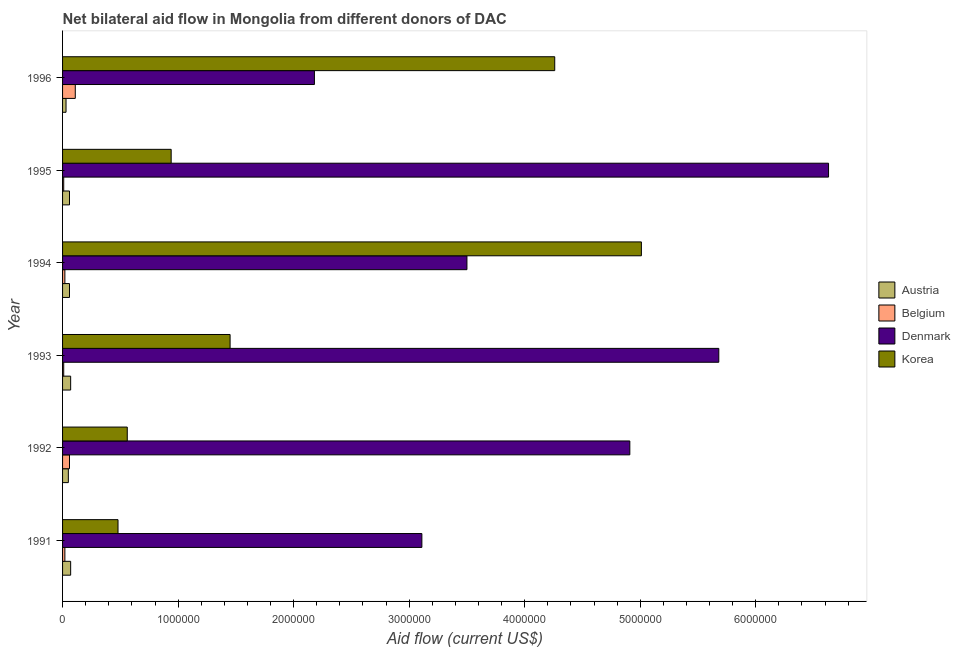How many different coloured bars are there?
Offer a very short reply. 4. Are the number of bars per tick equal to the number of legend labels?
Keep it short and to the point. Yes. Are the number of bars on each tick of the Y-axis equal?
Your answer should be compact. Yes. How many bars are there on the 1st tick from the top?
Offer a very short reply. 4. In how many cases, is the number of bars for a given year not equal to the number of legend labels?
Ensure brevity in your answer.  0. What is the amount of aid given by korea in 1993?
Your answer should be compact. 1.45e+06. Across all years, what is the maximum amount of aid given by austria?
Your response must be concise. 7.00e+04. Across all years, what is the minimum amount of aid given by austria?
Your answer should be very brief. 3.00e+04. In which year was the amount of aid given by korea maximum?
Provide a succinct answer. 1994. In which year was the amount of aid given by austria minimum?
Ensure brevity in your answer.  1996. What is the total amount of aid given by belgium in the graph?
Your answer should be very brief. 2.30e+05. What is the difference between the amount of aid given by austria in 1995 and that in 1996?
Keep it short and to the point. 3.00e+04. What is the average amount of aid given by belgium per year?
Keep it short and to the point. 3.83e+04. In the year 1996, what is the difference between the amount of aid given by austria and amount of aid given by belgium?
Offer a very short reply. -8.00e+04. In how many years, is the amount of aid given by austria greater than 2400000 US$?
Provide a short and direct response. 0. What is the ratio of the amount of aid given by korea in 1994 to that in 1996?
Keep it short and to the point. 1.18. Is the amount of aid given by austria in 1993 less than that in 1995?
Ensure brevity in your answer.  No. What is the difference between the highest and the second highest amount of aid given by korea?
Your answer should be very brief. 7.50e+05. What is the difference between the highest and the lowest amount of aid given by denmark?
Offer a very short reply. 4.45e+06. What does the 3rd bar from the bottom in 1991 represents?
Offer a terse response. Denmark. Are all the bars in the graph horizontal?
Your answer should be compact. Yes. How many years are there in the graph?
Ensure brevity in your answer.  6. Does the graph contain any zero values?
Your answer should be compact. No. What is the title of the graph?
Make the answer very short. Net bilateral aid flow in Mongolia from different donors of DAC. Does "Custom duties" appear as one of the legend labels in the graph?
Offer a terse response. No. What is the label or title of the X-axis?
Offer a terse response. Aid flow (current US$). What is the label or title of the Y-axis?
Give a very brief answer. Year. What is the Aid flow (current US$) in Denmark in 1991?
Your answer should be very brief. 3.11e+06. What is the Aid flow (current US$) in Korea in 1991?
Ensure brevity in your answer.  4.80e+05. What is the Aid flow (current US$) of Austria in 1992?
Keep it short and to the point. 5.00e+04. What is the Aid flow (current US$) in Denmark in 1992?
Offer a very short reply. 4.91e+06. What is the Aid flow (current US$) in Korea in 1992?
Your response must be concise. 5.60e+05. What is the Aid flow (current US$) of Denmark in 1993?
Provide a succinct answer. 5.68e+06. What is the Aid flow (current US$) in Korea in 1993?
Ensure brevity in your answer.  1.45e+06. What is the Aid flow (current US$) in Austria in 1994?
Your response must be concise. 6.00e+04. What is the Aid flow (current US$) of Denmark in 1994?
Provide a succinct answer. 3.50e+06. What is the Aid flow (current US$) in Korea in 1994?
Offer a very short reply. 5.01e+06. What is the Aid flow (current US$) in Austria in 1995?
Provide a short and direct response. 6.00e+04. What is the Aid flow (current US$) of Denmark in 1995?
Your answer should be very brief. 6.63e+06. What is the Aid flow (current US$) in Korea in 1995?
Offer a very short reply. 9.40e+05. What is the Aid flow (current US$) of Denmark in 1996?
Provide a succinct answer. 2.18e+06. What is the Aid flow (current US$) of Korea in 1996?
Give a very brief answer. 4.26e+06. Across all years, what is the maximum Aid flow (current US$) of Austria?
Keep it short and to the point. 7.00e+04. Across all years, what is the maximum Aid flow (current US$) in Denmark?
Offer a very short reply. 6.63e+06. Across all years, what is the maximum Aid flow (current US$) of Korea?
Ensure brevity in your answer.  5.01e+06. Across all years, what is the minimum Aid flow (current US$) of Austria?
Your answer should be compact. 3.00e+04. Across all years, what is the minimum Aid flow (current US$) of Denmark?
Keep it short and to the point. 2.18e+06. Across all years, what is the minimum Aid flow (current US$) of Korea?
Your answer should be compact. 4.80e+05. What is the total Aid flow (current US$) of Denmark in the graph?
Your answer should be very brief. 2.60e+07. What is the total Aid flow (current US$) of Korea in the graph?
Offer a very short reply. 1.27e+07. What is the difference between the Aid flow (current US$) in Austria in 1991 and that in 1992?
Your answer should be compact. 2.00e+04. What is the difference between the Aid flow (current US$) in Denmark in 1991 and that in 1992?
Offer a terse response. -1.80e+06. What is the difference between the Aid flow (current US$) of Korea in 1991 and that in 1992?
Make the answer very short. -8.00e+04. What is the difference between the Aid flow (current US$) of Denmark in 1991 and that in 1993?
Offer a terse response. -2.57e+06. What is the difference between the Aid flow (current US$) in Korea in 1991 and that in 1993?
Provide a short and direct response. -9.70e+05. What is the difference between the Aid flow (current US$) in Belgium in 1991 and that in 1994?
Ensure brevity in your answer.  0. What is the difference between the Aid flow (current US$) in Denmark in 1991 and that in 1994?
Offer a very short reply. -3.90e+05. What is the difference between the Aid flow (current US$) of Korea in 1991 and that in 1994?
Provide a succinct answer. -4.53e+06. What is the difference between the Aid flow (current US$) of Austria in 1991 and that in 1995?
Provide a succinct answer. 10000. What is the difference between the Aid flow (current US$) of Belgium in 1991 and that in 1995?
Keep it short and to the point. 10000. What is the difference between the Aid flow (current US$) in Denmark in 1991 and that in 1995?
Offer a very short reply. -3.52e+06. What is the difference between the Aid flow (current US$) of Korea in 1991 and that in 1995?
Provide a short and direct response. -4.60e+05. What is the difference between the Aid flow (current US$) in Belgium in 1991 and that in 1996?
Give a very brief answer. -9.00e+04. What is the difference between the Aid flow (current US$) in Denmark in 1991 and that in 1996?
Give a very brief answer. 9.30e+05. What is the difference between the Aid flow (current US$) of Korea in 1991 and that in 1996?
Provide a short and direct response. -3.78e+06. What is the difference between the Aid flow (current US$) in Belgium in 1992 and that in 1993?
Your answer should be compact. 5.00e+04. What is the difference between the Aid flow (current US$) of Denmark in 1992 and that in 1993?
Your answer should be compact. -7.70e+05. What is the difference between the Aid flow (current US$) in Korea in 1992 and that in 1993?
Provide a short and direct response. -8.90e+05. What is the difference between the Aid flow (current US$) of Austria in 1992 and that in 1994?
Provide a succinct answer. -10000. What is the difference between the Aid flow (current US$) of Belgium in 1992 and that in 1994?
Provide a short and direct response. 4.00e+04. What is the difference between the Aid flow (current US$) in Denmark in 1992 and that in 1994?
Provide a short and direct response. 1.41e+06. What is the difference between the Aid flow (current US$) in Korea in 1992 and that in 1994?
Your answer should be very brief. -4.45e+06. What is the difference between the Aid flow (current US$) in Austria in 1992 and that in 1995?
Your answer should be very brief. -10000. What is the difference between the Aid flow (current US$) in Denmark in 1992 and that in 1995?
Offer a terse response. -1.72e+06. What is the difference between the Aid flow (current US$) in Korea in 1992 and that in 1995?
Offer a terse response. -3.80e+05. What is the difference between the Aid flow (current US$) in Austria in 1992 and that in 1996?
Your response must be concise. 2.00e+04. What is the difference between the Aid flow (current US$) of Belgium in 1992 and that in 1996?
Your answer should be compact. -5.00e+04. What is the difference between the Aid flow (current US$) in Denmark in 1992 and that in 1996?
Offer a very short reply. 2.73e+06. What is the difference between the Aid flow (current US$) of Korea in 1992 and that in 1996?
Offer a very short reply. -3.70e+06. What is the difference between the Aid flow (current US$) of Belgium in 1993 and that in 1994?
Ensure brevity in your answer.  -10000. What is the difference between the Aid flow (current US$) in Denmark in 1993 and that in 1994?
Provide a short and direct response. 2.18e+06. What is the difference between the Aid flow (current US$) of Korea in 1993 and that in 1994?
Ensure brevity in your answer.  -3.56e+06. What is the difference between the Aid flow (current US$) of Austria in 1993 and that in 1995?
Offer a very short reply. 10000. What is the difference between the Aid flow (current US$) of Denmark in 1993 and that in 1995?
Offer a very short reply. -9.50e+05. What is the difference between the Aid flow (current US$) of Korea in 1993 and that in 1995?
Ensure brevity in your answer.  5.10e+05. What is the difference between the Aid flow (current US$) of Belgium in 1993 and that in 1996?
Give a very brief answer. -1.00e+05. What is the difference between the Aid flow (current US$) in Denmark in 1993 and that in 1996?
Make the answer very short. 3.50e+06. What is the difference between the Aid flow (current US$) in Korea in 1993 and that in 1996?
Offer a very short reply. -2.81e+06. What is the difference between the Aid flow (current US$) in Belgium in 1994 and that in 1995?
Provide a succinct answer. 10000. What is the difference between the Aid flow (current US$) of Denmark in 1994 and that in 1995?
Give a very brief answer. -3.13e+06. What is the difference between the Aid flow (current US$) in Korea in 1994 and that in 1995?
Your answer should be very brief. 4.07e+06. What is the difference between the Aid flow (current US$) in Belgium in 1994 and that in 1996?
Provide a succinct answer. -9.00e+04. What is the difference between the Aid flow (current US$) of Denmark in 1994 and that in 1996?
Your answer should be very brief. 1.32e+06. What is the difference between the Aid flow (current US$) in Korea in 1994 and that in 1996?
Provide a short and direct response. 7.50e+05. What is the difference between the Aid flow (current US$) in Austria in 1995 and that in 1996?
Make the answer very short. 3.00e+04. What is the difference between the Aid flow (current US$) of Belgium in 1995 and that in 1996?
Offer a terse response. -1.00e+05. What is the difference between the Aid flow (current US$) of Denmark in 1995 and that in 1996?
Keep it short and to the point. 4.45e+06. What is the difference between the Aid flow (current US$) in Korea in 1995 and that in 1996?
Provide a succinct answer. -3.32e+06. What is the difference between the Aid flow (current US$) in Austria in 1991 and the Aid flow (current US$) in Belgium in 1992?
Offer a very short reply. 10000. What is the difference between the Aid flow (current US$) of Austria in 1991 and the Aid flow (current US$) of Denmark in 1992?
Your answer should be very brief. -4.84e+06. What is the difference between the Aid flow (current US$) of Austria in 1991 and the Aid flow (current US$) of Korea in 1992?
Ensure brevity in your answer.  -4.90e+05. What is the difference between the Aid flow (current US$) in Belgium in 1991 and the Aid flow (current US$) in Denmark in 1992?
Offer a terse response. -4.89e+06. What is the difference between the Aid flow (current US$) in Belgium in 1991 and the Aid flow (current US$) in Korea in 1992?
Your response must be concise. -5.40e+05. What is the difference between the Aid flow (current US$) in Denmark in 1991 and the Aid flow (current US$) in Korea in 1992?
Offer a terse response. 2.55e+06. What is the difference between the Aid flow (current US$) of Austria in 1991 and the Aid flow (current US$) of Belgium in 1993?
Your answer should be compact. 6.00e+04. What is the difference between the Aid flow (current US$) of Austria in 1991 and the Aid flow (current US$) of Denmark in 1993?
Ensure brevity in your answer.  -5.61e+06. What is the difference between the Aid flow (current US$) in Austria in 1991 and the Aid flow (current US$) in Korea in 1993?
Provide a succinct answer. -1.38e+06. What is the difference between the Aid flow (current US$) of Belgium in 1991 and the Aid flow (current US$) of Denmark in 1993?
Provide a short and direct response. -5.66e+06. What is the difference between the Aid flow (current US$) of Belgium in 1991 and the Aid flow (current US$) of Korea in 1993?
Offer a very short reply. -1.43e+06. What is the difference between the Aid flow (current US$) of Denmark in 1991 and the Aid flow (current US$) of Korea in 1993?
Your response must be concise. 1.66e+06. What is the difference between the Aid flow (current US$) in Austria in 1991 and the Aid flow (current US$) in Belgium in 1994?
Offer a terse response. 5.00e+04. What is the difference between the Aid flow (current US$) in Austria in 1991 and the Aid flow (current US$) in Denmark in 1994?
Offer a terse response. -3.43e+06. What is the difference between the Aid flow (current US$) in Austria in 1991 and the Aid flow (current US$) in Korea in 1994?
Offer a terse response. -4.94e+06. What is the difference between the Aid flow (current US$) of Belgium in 1991 and the Aid flow (current US$) of Denmark in 1994?
Provide a succinct answer. -3.48e+06. What is the difference between the Aid flow (current US$) in Belgium in 1991 and the Aid flow (current US$) in Korea in 1994?
Provide a succinct answer. -4.99e+06. What is the difference between the Aid flow (current US$) in Denmark in 1991 and the Aid flow (current US$) in Korea in 1994?
Give a very brief answer. -1.90e+06. What is the difference between the Aid flow (current US$) of Austria in 1991 and the Aid flow (current US$) of Denmark in 1995?
Your response must be concise. -6.56e+06. What is the difference between the Aid flow (current US$) in Austria in 1991 and the Aid flow (current US$) in Korea in 1995?
Keep it short and to the point. -8.70e+05. What is the difference between the Aid flow (current US$) in Belgium in 1991 and the Aid flow (current US$) in Denmark in 1995?
Offer a very short reply. -6.61e+06. What is the difference between the Aid flow (current US$) of Belgium in 1991 and the Aid flow (current US$) of Korea in 1995?
Give a very brief answer. -9.20e+05. What is the difference between the Aid flow (current US$) of Denmark in 1991 and the Aid flow (current US$) of Korea in 1995?
Provide a short and direct response. 2.17e+06. What is the difference between the Aid flow (current US$) of Austria in 1991 and the Aid flow (current US$) of Belgium in 1996?
Your answer should be very brief. -4.00e+04. What is the difference between the Aid flow (current US$) in Austria in 1991 and the Aid flow (current US$) in Denmark in 1996?
Offer a very short reply. -2.11e+06. What is the difference between the Aid flow (current US$) of Austria in 1991 and the Aid flow (current US$) of Korea in 1996?
Your answer should be very brief. -4.19e+06. What is the difference between the Aid flow (current US$) of Belgium in 1991 and the Aid flow (current US$) of Denmark in 1996?
Offer a very short reply. -2.16e+06. What is the difference between the Aid flow (current US$) in Belgium in 1991 and the Aid flow (current US$) in Korea in 1996?
Make the answer very short. -4.24e+06. What is the difference between the Aid flow (current US$) of Denmark in 1991 and the Aid flow (current US$) of Korea in 1996?
Offer a very short reply. -1.15e+06. What is the difference between the Aid flow (current US$) in Austria in 1992 and the Aid flow (current US$) in Denmark in 1993?
Your response must be concise. -5.63e+06. What is the difference between the Aid flow (current US$) of Austria in 1992 and the Aid flow (current US$) of Korea in 1993?
Provide a succinct answer. -1.40e+06. What is the difference between the Aid flow (current US$) of Belgium in 1992 and the Aid flow (current US$) of Denmark in 1993?
Your answer should be very brief. -5.62e+06. What is the difference between the Aid flow (current US$) in Belgium in 1992 and the Aid flow (current US$) in Korea in 1993?
Offer a very short reply. -1.39e+06. What is the difference between the Aid flow (current US$) of Denmark in 1992 and the Aid flow (current US$) of Korea in 1993?
Ensure brevity in your answer.  3.46e+06. What is the difference between the Aid flow (current US$) of Austria in 1992 and the Aid flow (current US$) of Denmark in 1994?
Ensure brevity in your answer.  -3.45e+06. What is the difference between the Aid flow (current US$) of Austria in 1992 and the Aid flow (current US$) of Korea in 1994?
Provide a succinct answer. -4.96e+06. What is the difference between the Aid flow (current US$) of Belgium in 1992 and the Aid flow (current US$) of Denmark in 1994?
Make the answer very short. -3.44e+06. What is the difference between the Aid flow (current US$) of Belgium in 1992 and the Aid flow (current US$) of Korea in 1994?
Provide a succinct answer. -4.95e+06. What is the difference between the Aid flow (current US$) in Denmark in 1992 and the Aid flow (current US$) in Korea in 1994?
Give a very brief answer. -1.00e+05. What is the difference between the Aid flow (current US$) of Austria in 1992 and the Aid flow (current US$) of Denmark in 1995?
Your answer should be compact. -6.58e+06. What is the difference between the Aid flow (current US$) in Austria in 1992 and the Aid flow (current US$) in Korea in 1995?
Offer a very short reply. -8.90e+05. What is the difference between the Aid flow (current US$) of Belgium in 1992 and the Aid flow (current US$) of Denmark in 1995?
Your answer should be compact. -6.57e+06. What is the difference between the Aid flow (current US$) of Belgium in 1992 and the Aid flow (current US$) of Korea in 1995?
Keep it short and to the point. -8.80e+05. What is the difference between the Aid flow (current US$) of Denmark in 1992 and the Aid flow (current US$) of Korea in 1995?
Give a very brief answer. 3.97e+06. What is the difference between the Aid flow (current US$) in Austria in 1992 and the Aid flow (current US$) in Denmark in 1996?
Ensure brevity in your answer.  -2.13e+06. What is the difference between the Aid flow (current US$) in Austria in 1992 and the Aid flow (current US$) in Korea in 1996?
Provide a succinct answer. -4.21e+06. What is the difference between the Aid flow (current US$) of Belgium in 1992 and the Aid flow (current US$) of Denmark in 1996?
Offer a terse response. -2.12e+06. What is the difference between the Aid flow (current US$) of Belgium in 1992 and the Aid flow (current US$) of Korea in 1996?
Your answer should be very brief. -4.20e+06. What is the difference between the Aid flow (current US$) of Denmark in 1992 and the Aid flow (current US$) of Korea in 1996?
Give a very brief answer. 6.50e+05. What is the difference between the Aid flow (current US$) in Austria in 1993 and the Aid flow (current US$) in Belgium in 1994?
Your answer should be compact. 5.00e+04. What is the difference between the Aid flow (current US$) in Austria in 1993 and the Aid flow (current US$) in Denmark in 1994?
Your response must be concise. -3.43e+06. What is the difference between the Aid flow (current US$) in Austria in 1993 and the Aid flow (current US$) in Korea in 1994?
Keep it short and to the point. -4.94e+06. What is the difference between the Aid flow (current US$) of Belgium in 1993 and the Aid flow (current US$) of Denmark in 1994?
Offer a very short reply. -3.49e+06. What is the difference between the Aid flow (current US$) of Belgium in 1993 and the Aid flow (current US$) of Korea in 1994?
Your answer should be compact. -5.00e+06. What is the difference between the Aid flow (current US$) of Denmark in 1993 and the Aid flow (current US$) of Korea in 1994?
Give a very brief answer. 6.70e+05. What is the difference between the Aid flow (current US$) of Austria in 1993 and the Aid flow (current US$) of Belgium in 1995?
Make the answer very short. 6.00e+04. What is the difference between the Aid flow (current US$) in Austria in 1993 and the Aid flow (current US$) in Denmark in 1995?
Offer a very short reply. -6.56e+06. What is the difference between the Aid flow (current US$) of Austria in 1993 and the Aid flow (current US$) of Korea in 1995?
Provide a succinct answer. -8.70e+05. What is the difference between the Aid flow (current US$) of Belgium in 1993 and the Aid flow (current US$) of Denmark in 1995?
Your response must be concise. -6.62e+06. What is the difference between the Aid flow (current US$) of Belgium in 1993 and the Aid flow (current US$) of Korea in 1995?
Your answer should be very brief. -9.30e+05. What is the difference between the Aid flow (current US$) of Denmark in 1993 and the Aid flow (current US$) of Korea in 1995?
Your answer should be compact. 4.74e+06. What is the difference between the Aid flow (current US$) of Austria in 1993 and the Aid flow (current US$) of Belgium in 1996?
Offer a terse response. -4.00e+04. What is the difference between the Aid flow (current US$) of Austria in 1993 and the Aid flow (current US$) of Denmark in 1996?
Keep it short and to the point. -2.11e+06. What is the difference between the Aid flow (current US$) in Austria in 1993 and the Aid flow (current US$) in Korea in 1996?
Your answer should be compact. -4.19e+06. What is the difference between the Aid flow (current US$) of Belgium in 1993 and the Aid flow (current US$) of Denmark in 1996?
Provide a succinct answer. -2.17e+06. What is the difference between the Aid flow (current US$) of Belgium in 1993 and the Aid flow (current US$) of Korea in 1996?
Ensure brevity in your answer.  -4.25e+06. What is the difference between the Aid flow (current US$) of Denmark in 1993 and the Aid flow (current US$) of Korea in 1996?
Your response must be concise. 1.42e+06. What is the difference between the Aid flow (current US$) in Austria in 1994 and the Aid flow (current US$) in Belgium in 1995?
Make the answer very short. 5.00e+04. What is the difference between the Aid flow (current US$) of Austria in 1994 and the Aid flow (current US$) of Denmark in 1995?
Give a very brief answer. -6.57e+06. What is the difference between the Aid flow (current US$) in Austria in 1994 and the Aid flow (current US$) in Korea in 1995?
Ensure brevity in your answer.  -8.80e+05. What is the difference between the Aid flow (current US$) in Belgium in 1994 and the Aid flow (current US$) in Denmark in 1995?
Your response must be concise. -6.61e+06. What is the difference between the Aid flow (current US$) in Belgium in 1994 and the Aid flow (current US$) in Korea in 1995?
Provide a succinct answer. -9.20e+05. What is the difference between the Aid flow (current US$) in Denmark in 1994 and the Aid flow (current US$) in Korea in 1995?
Provide a succinct answer. 2.56e+06. What is the difference between the Aid flow (current US$) of Austria in 1994 and the Aid flow (current US$) of Denmark in 1996?
Give a very brief answer. -2.12e+06. What is the difference between the Aid flow (current US$) of Austria in 1994 and the Aid flow (current US$) of Korea in 1996?
Offer a very short reply. -4.20e+06. What is the difference between the Aid flow (current US$) in Belgium in 1994 and the Aid flow (current US$) in Denmark in 1996?
Your answer should be compact. -2.16e+06. What is the difference between the Aid flow (current US$) in Belgium in 1994 and the Aid flow (current US$) in Korea in 1996?
Give a very brief answer. -4.24e+06. What is the difference between the Aid flow (current US$) in Denmark in 1994 and the Aid flow (current US$) in Korea in 1996?
Give a very brief answer. -7.60e+05. What is the difference between the Aid flow (current US$) in Austria in 1995 and the Aid flow (current US$) in Belgium in 1996?
Your answer should be very brief. -5.00e+04. What is the difference between the Aid flow (current US$) of Austria in 1995 and the Aid flow (current US$) of Denmark in 1996?
Provide a succinct answer. -2.12e+06. What is the difference between the Aid flow (current US$) in Austria in 1995 and the Aid flow (current US$) in Korea in 1996?
Provide a short and direct response. -4.20e+06. What is the difference between the Aid flow (current US$) of Belgium in 1995 and the Aid flow (current US$) of Denmark in 1996?
Offer a very short reply. -2.17e+06. What is the difference between the Aid flow (current US$) of Belgium in 1995 and the Aid flow (current US$) of Korea in 1996?
Your answer should be compact. -4.25e+06. What is the difference between the Aid flow (current US$) in Denmark in 1995 and the Aid flow (current US$) in Korea in 1996?
Your answer should be very brief. 2.37e+06. What is the average Aid flow (current US$) of Austria per year?
Provide a succinct answer. 5.67e+04. What is the average Aid flow (current US$) of Belgium per year?
Ensure brevity in your answer.  3.83e+04. What is the average Aid flow (current US$) in Denmark per year?
Keep it short and to the point. 4.34e+06. What is the average Aid flow (current US$) of Korea per year?
Keep it short and to the point. 2.12e+06. In the year 1991, what is the difference between the Aid flow (current US$) in Austria and Aid flow (current US$) in Belgium?
Offer a terse response. 5.00e+04. In the year 1991, what is the difference between the Aid flow (current US$) of Austria and Aid flow (current US$) of Denmark?
Your response must be concise. -3.04e+06. In the year 1991, what is the difference between the Aid flow (current US$) of Austria and Aid flow (current US$) of Korea?
Make the answer very short. -4.10e+05. In the year 1991, what is the difference between the Aid flow (current US$) in Belgium and Aid flow (current US$) in Denmark?
Your answer should be compact. -3.09e+06. In the year 1991, what is the difference between the Aid flow (current US$) in Belgium and Aid flow (current US$) in Korea?
Ensure brevity in your answer.  -4.60e+05. In the year 1991, what is the difference between the Aid flow (current US$) of Denmark and Aid flow (current US$) of Korea?
Offer a terse response. 2.63e+06. In the year 1992, what is the difference between the Aid flow (current US$) in Austria and Aid flow (current US$) in Belgium?
Ensure brevity in your answer.  -10000. In the year 1992, what is the difference between the Aid flow (current US$) in Austria and Aid flow (current US$) in Denmark?
Your response must be concise. -4.86e+06. In the year 1992, what is the difference between the Aid flow (current US$) in Austria and Aid flow (current US$) in Korea?
Offer a terse response. -5.10e+05. In the year 1992, what is the difference between the Aid flow (current US$) of Belgium and Aid flow (current US$) of Denmark?
Offer a very short reply. -4.85e+06. In the year 1992, what is the difference between the Aid flow (current US$) of Belgium and Aid flow (current US$) of Korea?
Offer a very short reply. -5.00e+05. In the year 1992, what is the difference between the Aid flow (current US$) of Denmark and Aid flow (current US$) of Korea?
Your answer should be compact. 4.35e+06. In the year 1993, what is the difference between the Aid flow (current US$) of Austria and Aid flow (current US$) of Denmark?
Offer a terse response. -5.61e+06. In the year 1993, what is the difference between the Aid flow (current US$) in Austria and Aid flow (current US$) in Korea?
Offer a terse response. -1.38e+06. In the year 1993, what is the difference between the Aid flow (current US$) in Belgium and Aid flow (current US$) in Denmark?
Provide a succinct answer. -5.67e+06. In the year 1993, what is the difference between the Aid flow (current US$) in Belgium and Aid flow (current US$) in Korea?
Your response must be concise. -1.44e+06. In the year 1993, what is the difference between the Aid flow (current US$) of Denmark and Aid flow (current US$) of Korea?
Provide a succinct answer. 4.23e+06. In the year 1994, what is the difference between the Aid flow (current US$) of Austria and Aid flow (current US$) of Belgium?
Offer a very short reply. 4.00e+04. In the year 1994, what is the difference between the Aid flow (current US$) of Austria and Aid flow (current US$) of Denmark?
Your response must be concise. -3.44e+06. In the year 1994, what is the difference between the Aid flow (current US$) in Austria and Aid flow (current US$) in Korea?
Offer a very short reply. -4.95e+06. In the year 1994, what is the difference between the Aid flow (current US$) in Belgium and Aid flow (current US$) in Denmark?
Provide a short and direct response. -3.48e+06. In the year 1994, what is the difference between the Aid flow (current US$) in Belgium and Aid flow (current US$) in Korea?
Provide a succinct answer. -4.99e+06. In the year 1994, what is the difference between the Aid flow (current US$) in Denmark and Aid flow (current US$) in Korea?
Provide a succinct answer. -1.51e+06. In the year 1995, what is the difference between the Aid flow (current US$) of Austria and Aid flow (current US$) of Belgium?
Your response must be concise. 5.00e+04. In the year 1995, what is the difference between the Aid flow (current US$) of Austria and Aid flow (current US$) of Denmark?
Ensure brevity in your answer.  -6.57e+06. In the year 1995, what is the difference between the Aid flow (current US$) in Austria and Aid flow (current US$) in Korea?
Your response must be concise. -8.80e+05. In the year 1995, what is the difference between the Aid flow (current US$) of Belgium and Aid flow (current US$) of Denmark?
Offer a terse response. -6.62e+06. In the year 1995, what is the difference between the Aid flow (current US$) of Belgium and Aid flow (current US$) of Korea?
Ensure brevity in your answer.  -9.30e+05. In the year 1995, what is the difference between the Aid flow (current US$) in Denmark and Aid flow (current US$) in Korea?
Your response must be concise. 5.69e+06. In the year 1996, what is the difference between the Aid flow (current US$) of Austria and Aid flow (current US$) of Denmark?
Provide a succinct answer. -2.15e+06. In the year 1996, what is the difference between the Aid flow (current US$) of Austria and Aid flow (current US$) of Korea?
Make the answer very short. -4.23e+06. In the year 1996, what is the difference between the Aid flow (current US$) in Belgium and Aid flow (current US$) in Denmark?
Ensure brevity in your answer.  -2.07e+06. In the year 1996, what is the difference between the Aid flow (current US$) of Belgium and Aid flow (current US$) of Korea?
Keep it short and to the point. -4.15e+06. In the year 1996, what is the difference between the Aid flow (current US$) of Denmark and Aid flow (current US$) of Korea?
Make the answer very short. -2.08e+06. What is the ratio of the Aid flow (current US$) in Austria in 1991 to that in 1992?
Make the answer very short. 1.4. What is the ratio of the Aid flow (current US$) of Belgium in 1991 to that in 1992?
Keep it short and to the point. 0.33. What is the ratio of the Aid flow (current US$) in Denmark in 1991 to that in 1992?
Offer a very short reply. 0.63. What is the ratio of the Aid flow (current US$) in Denmark in 1991 to that in 1993?
Your answer should be very brief. 0.55. What is the ratio of the Aid flow (current US$) in Korea in 1991 to that in 1993?
Offer a very short reply. 0.33. What is the ratio of the Aid flow (current US$) in Belgium in 1991 to that in 1994?
Your response must be concise. 1. What is the ratio of the Aid flow (current US$) of Denmark in 1991 to that in 1994?
Provide a short and direct response. 0.89. What is the ratio of the Aid flow (current US$) of Korea in 1991 to that in 1994?
Your answer should be compact. 0.1. What is the ratio of the Aid flow (current US$) of Denmark in 1991 to that in 1995?
Your answer should be very brief. 0.47. What is the ratio of the Aid flow (current US$) of Korea in 1991 to that in 1995?
Give a very brief answer. 0.51. What is the ratio of the Aid flow (current US$) in Austria in 1991 to that in 1996?
Your response must be concise. 2.33. What is the ratio of the Aid flow (current US$) of Belgium in 1991 to that in 1996?
Ensure brevity in your answer.  0.18. What is the ratio of the Aid flow (current US$) of Denmark in 1991 to that in 1996?
Make the answer very short. 1.43. What is the ratio of the Aid flow (current US$) in Korea in 1991 to that in 1996?
Make the answer very short. 0.11. What is the ratio of the Aid flow (current US$) in Belgium in 1992 to that in 1993?
Your response must be concise. 6. What is the ratio of the Aid flow (current US$) of Denmark in 1992 to that in 1993?
Ensure brevity in your answer.  0.86. What is the ratio of the Aid flow (current US$) in Korea in 1992 to that in 1993?
Ensure brevity in your answer.  0.39. What is the ratio of the Aid flow (current US$) in Austria in 1992 to that in 1994?
Give a very brief answer. 0.83. What is the ratio of the Aid flow (current US$) in Belgium in 1992 to that in 1994?
Make the answer very short. 3. What is the ratio of the Aid flow (current US$) in Denmark in 1992 to that in 1994?
Provide a succinct answer. 1.4. What is the ratio of the Aid flow (current US$) of Korea in 1992 to that in 1994?
Ensure brevity in your answer.  0.11. What is the ratio of the Aid flow (current US$) of Belgium in 1992 to that in 1995?
Make the answer very short. 6. What is the ratio of the Aid flow (current US$) in Denmark in 1992 to that in 1995?
Give a very brief answer. 0.74. What is the ratio of the Aid flow (current US$) in Korea in 1992 to that in 1995?
Keep it short and to the point. 0.6. What is the ratio of the Aid flow (current US$) of Austria in 1992 to that in 1996?
Give a very brief answer. 1.67. What is the ratio of the Aid flow (current US$) in Belgium in 1992 to that in 1996?
Give a very brief answer. 0.55. What is the ratio of the Aid flow (current US$) in Denmark in 1992 to that in 1996?
Provide a succinct answer. 2.25. What is the ratio of the Aid flow (current US$) of Korea in 1992 to that in 1996?
Provide a short and direct response. 0.13. What is the ratio of the Aid flow (current US$) of Belgium in 1993 to that in 1994?
Keep it short and to the point. 0.5. What is the ratio of the Aid flow (current US$) of Denmark in 1993 to that in 1994?
Keep it short and to the point. 1.62. What is the ratio of the Aid flow (current US$) in Korea in 1993 to that in 1994?
Keep it short and to the point. 0.29. What is the ratio of the Aid flow (current US$) in Belgium in 1993 to that in 1995?
Give a very brief answer. 1. What is the ratio of the Aid flow (current US$) of Denmark in 1993 to that in 1995?
Provide a succinct answer. 0.86. What is the ratio of the Aid flow (current US$) in Korea in 1993 to that in 1995?
Ensure brevity in your answer.  1.54. What is the ratio of the Aid flow (current US$) of Austria in 1993 to that in 1996?
Ensure brevity in your answer.  2.33. What is the ratio of the Aid flow (current US$) of Belgium in 1993 to that in 1996?
Ensure brevity in your answer.  0.09. What is the ratio of the Aid flow (current US$) of Denmark in 1993 to that in 1996?
Provide a succinct answer. 2.61. What is the ratio of the Aid flow (current US$) in Korea in 1993 to that in 1996?
Provide a short and direct response. 0.34. What is the ratio of the Aid flow (current US$) of Austria in 1994 to that in 1995?
Offer a very short reply. 1. What is the ratio of the Aid flow (current US$) of Denmark in 1994 to that in 1995?
Provide a short and direct response. 0.53. What is the ratio of the Aid flow (current US$) in Korea in 1994 to that in 1995?
Your answer should be compact. 5.33. What is the ratio of the Aid flow (current US$) of Austria in 1994 to that in 1996?
Offer a very short reply. 2. What is the ratio of the Aid flow (current US$) in Belgium in 1994 to that in 1996?
Provide a succinct answer. 0.18. What is the ratio of the Aid flow (current US$) of Denmark in 1994 to that in 1996?
Your answer should be compact. 1.61. What is the ratio of the Aid flow (current US$) in Korea in 1994 to that in 1996?
Give a very brief answer. 1.18. What is the ratio of the Aid flow (current US$) in Belgium in 1995 to that in 1996?
Keep it short and to the point. 0.09. What is the ratio of the Aid flow (current US$) in Denmark in 1995 to that in 1996?
Keep it short and to the point. 3.04. What is the ratio of the Aid flow (current US$) in Korea in 1995 to that in 1996?
Make the answer very short. 0.22. What is the difference between the highest and the second highest Aid flow (current US$) of Austria?
Keep it short and to the point. 0. What is the difference between the highest and the second highest Aid flow (current US$) in Denmark?
Offer a very short reply. 9.50e+05. What is the difference between the highest and the second highest Aid flow (current US$) in Korea?
Ensure brevity in your answer.  7.50e+05. What is the difference between the highest and the lowest Aid flow (current US$) in Belgium?
Your response must be concise. 1.00e+05. What is the difference between the highest and the lowest Aid flow (current US$) in Denmark?
Your answer should be compact. 4.45e+06. What is the difference between the highest and the lowest Aid flow (current US$) in Korea?
Give a very brief answer. 4.53e+06. 